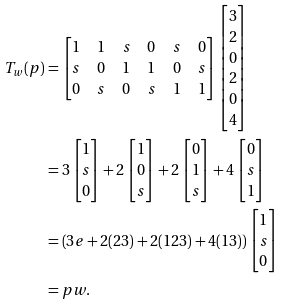Convert formula to latex. <formula><loc_0><loc_0><loc_500><loc_500>T _ { w } ( p ) & = \begin{bmatrix} 1 & 1 & s & 0 & s & 0 \\ s & 0 & 1 & 1 & 0 & s \\ 0 & s & 0 & s & 1 & 1 \end{bmatrix} \begin{bmatrix} 3 \\ 2 \\ 0 \\ 2 \\ 0 \\ 4 \end{bmatrix} \\ & = 3 \begin{bmatrix} 1 \\ s \\ 0 \end{bmatrix} + 2 \begin{bmatrix} 1 \\ 0 \\ s \end{bmatrix} + 2 \begin{bmatrix} 0 \\ 1 \\ s \end{bmatrix} + 4 \begin{bmatrix} 0 \\ s \\ 1 \end{bmatrix} \\ & = \left ( 3 e + 2 ( 2 3 ) + 2 ( 1 2 3 ) + 4 ( 1 3 ) \right ) \begin{bmatrix} 1 \\ s \\ 0 \end{bmatrix} \\ & = p w .</formula> 